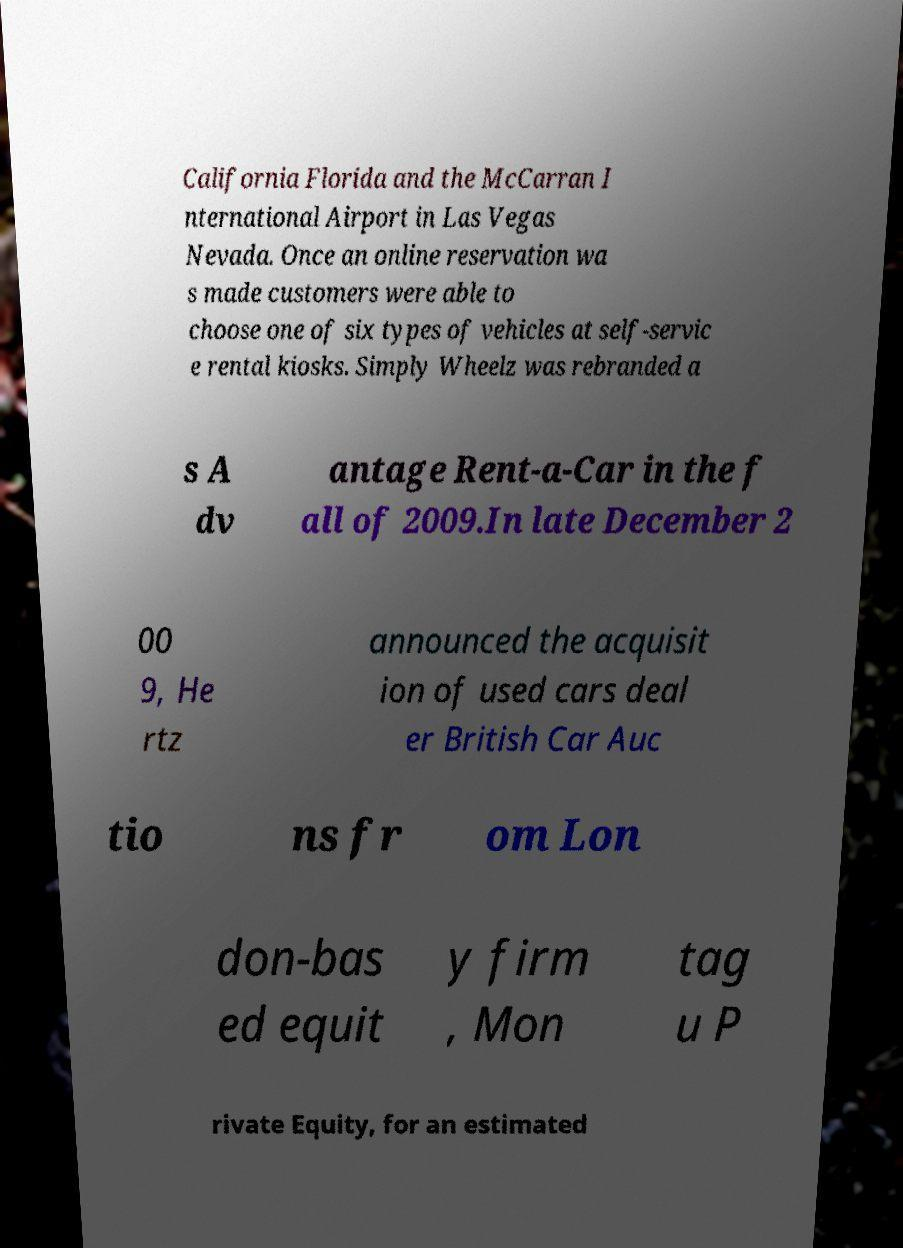Can you read and provide the text displayed in the image?This photo seems to have some interesting text. Can you extract and type it out for me? California Florida and the McCarran I nternational Airport in Las Vegas Nevada. Once an online reservation wa s made customers were able to choose one of six types of vehicles at self-servic e rental kiosks. Simply Wheelz was rebranded a s A dv antage Rent-a-Car in the f all of 2009.In late December 2 00 9, He rtz announced the acquisit ion of used cars deal er British Car Auc tio ns fr om Lon don-bas ed equit y firm , Mon tag u P rivate Equity, for an estimated 